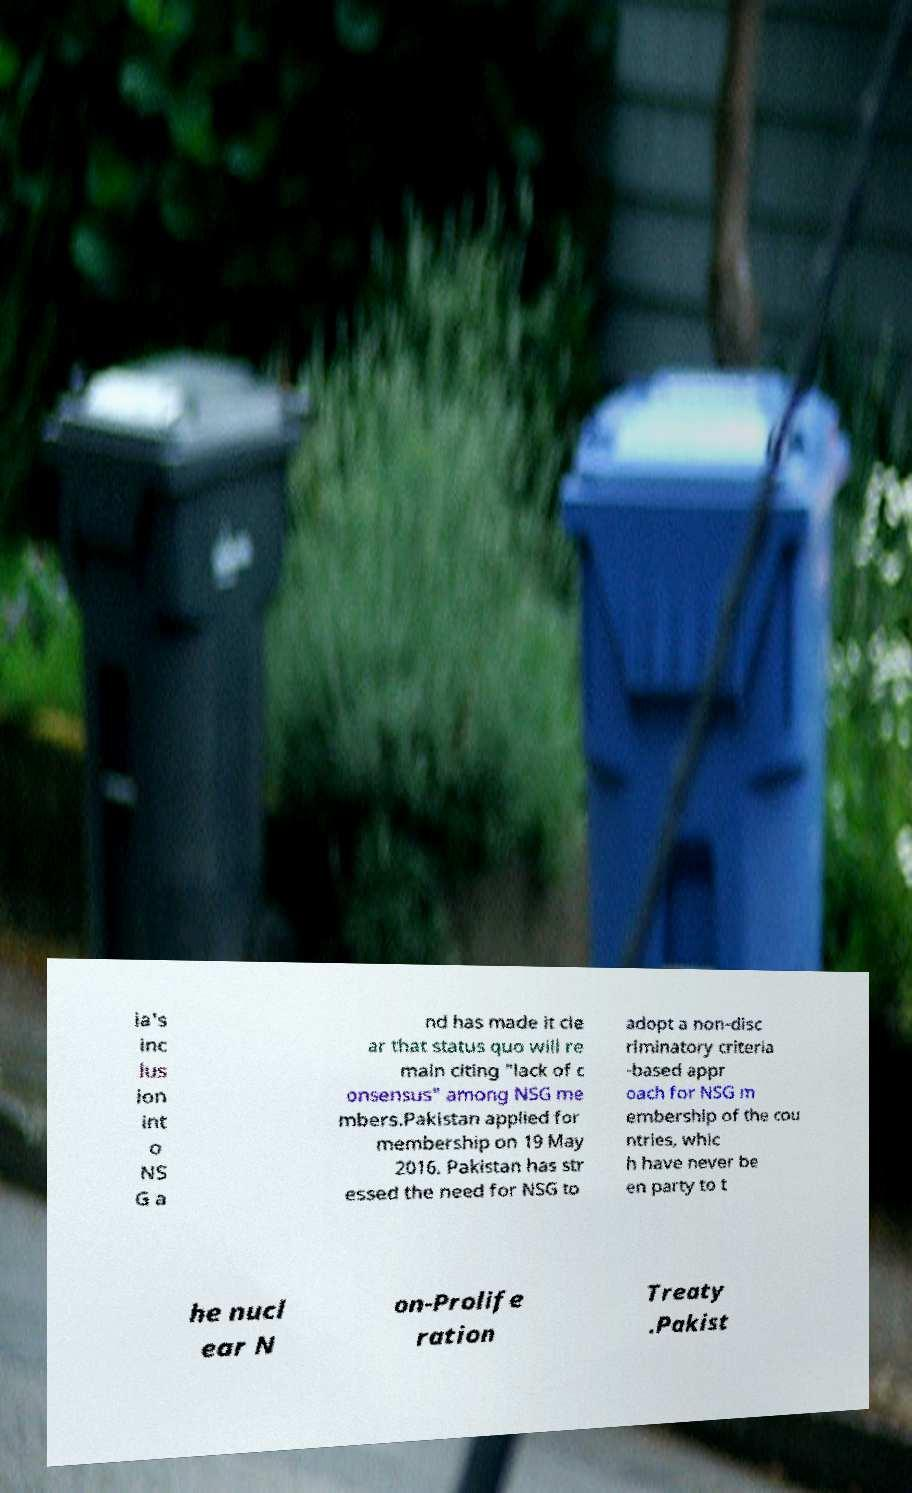Can you accurately transcribe the text from the provided image for me? ia's inc lus ion int o NS G a nd has made it cle ar that status quo will re main citing "lack of c onsensus" among NSG me mbers.Pakistan applied for membership on 19 May 2016. Pakistan has str essed the need for NSG to adopt a non-disc riminatory criteria -based appr oach for NSG m embership of the cou ntries, whic h have never be en party to t he nucl ear N on-Prolife ration Treaty .Pakist 